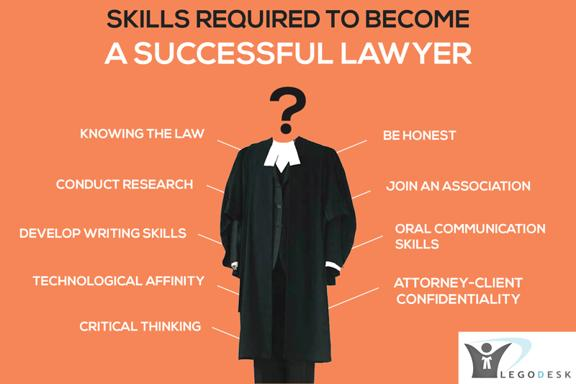What are some skills required to become a successful lawyer mentioned in the image? The image mentions the following skills required to become a successful lawyer:
1. Knowing the law
2. Being honest
3. Conducting research
4. Joining an association
5. Developing writing skills
6. Oral communication skills
7. Technological affinity
8. Maintaining attorney-client confidentiality
9. Critical thinking skills Why is it important for a lawyer to have good oral communication skills? Good oral communication skills are essential for a lawyer because they need to effectively present their client's case, argue their points convincingly, and persuade the judge or jury. Additionally, excellent oral communication skills help them to ask clear and concise questions while examining witnesses and to communicate with clients, colleagues, and other professionals in the legal field. 